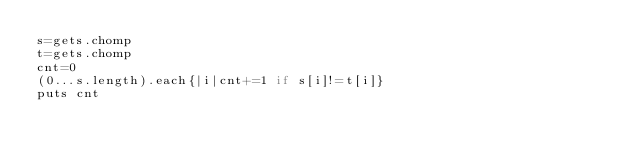Convert code to text. <code><loc_0><loc_0><loc_500><loc_500><_Ruby_>s=gets.chomp
t=gets.chomp
cnt=0
(0...s.length).each{|i|cnt+=1 if s[i]!=t[i]}
puts cnt</code> 